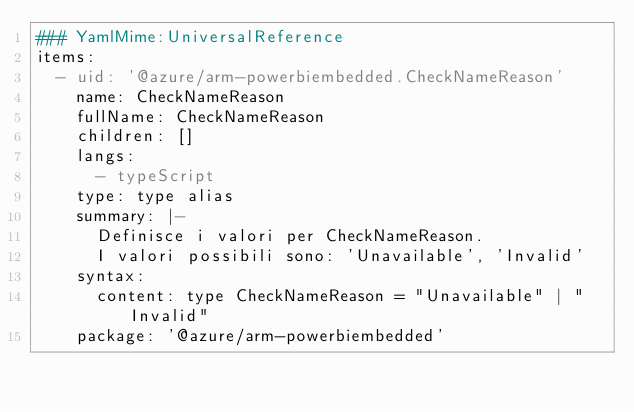<code> <loc_0><loc_0><loc_500><loc_500><_YAML_>### YamlMime:UniversalReference
items:
  - uid: '@azure/arm-powerbiembedded.CheckNameReason'
    name: CheckNameReason
    fullName: CheckNameReason
    children: []
    langs:
      - typeScript
    type: type alias
    summary: |-
      Definisce i valori per CheckNameReason.
      I valori possibili sono: 'Unavailable', 'Invalid'
    syntax:
      content: type CheckNameReason = "Unavailable" | "Invalid"
    package: '@azure/arm-powerbiembedded'</code> 